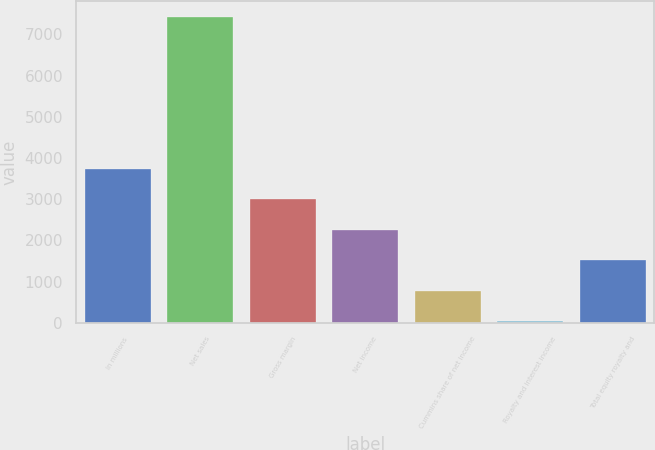Convert chart. <chart><loc_0><loc_0><loc_500><loc_500><bar_chart><fcel>In millions<fcel>Net sales<fcel>Gross margin<fcel>Net income<fcel>Cummins share of net income<fcel>Royalty and interest income<fcel>Total equity royalty and<nl><fcel>3733<fcel>7426<fcel>2994.4<fcel>2255.8<fcel>778.6<fcel>40<fcel>1517.2<nl></chart> 